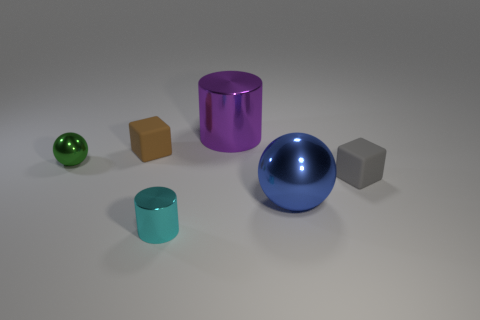Add 1 purple things. How many objects exist? 7 Subtract all cubes. How many objects are left? 4 Add 6 small cubes. How many small cubes are left? 8 Add 3 small green metal objects. How many small green metal objects exist? 4 Subtract 0 green cubes. How many objects are left? 6 Subtract all small metallic things. Subtract all small cubes. How many objects are left? 2 